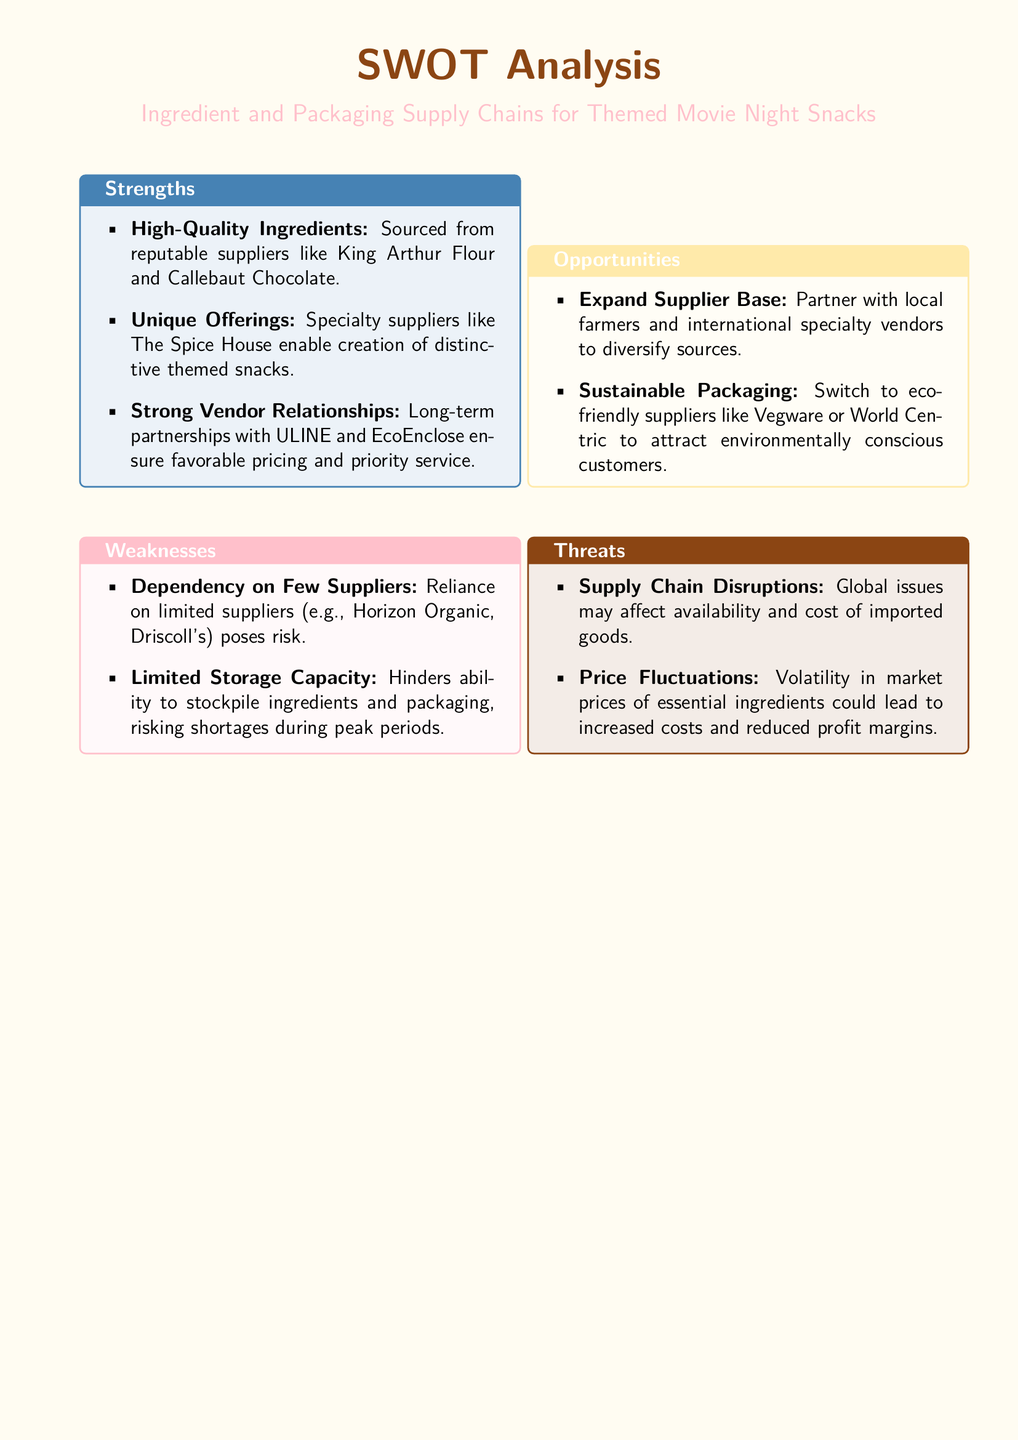what are the strengths listed in the SWOT analysis? The strengths outline key advantages like high-quality ingredients, unique offerings, and strong vendor relationships.
Answer: High-Quality Ingredients, Unique Offerings, Strong Vendor Relationships who are the specialty suppliers mentioned? The document specifies the suppliers who provide unique ingredients for themed snacks.
Answer: The Spice House what is a weakness related to supply dependency? The analysis highlights a specific risk associated with reliance on suppliers.
Answer: Dependency on Few Suppliers how many opportunities are identified in the SWOT analysis? The document outlines potential areas for growth and improvement in supplier relationships.
Answer: Two which supplier is mentioned for sustainable packaging? The document points to suppliers that focus on eco-friendly options for packaging.
Answer: Vegware what are the two threats identified regarding supply chains? The document lists major risks affecting ingredient and packaging supply chains.
Answer: Supply Chain Disruptions, Price Fluctuations which supplier is listed for high-quality flour? The document names a specific supplier known for its flour products.
Answer: King Arthur Flour how does limited storage capacity affect the bakery? The document indicates a specific impact of this weakness on the bakery's operations.
Answer: Risks shortages during peak periods 